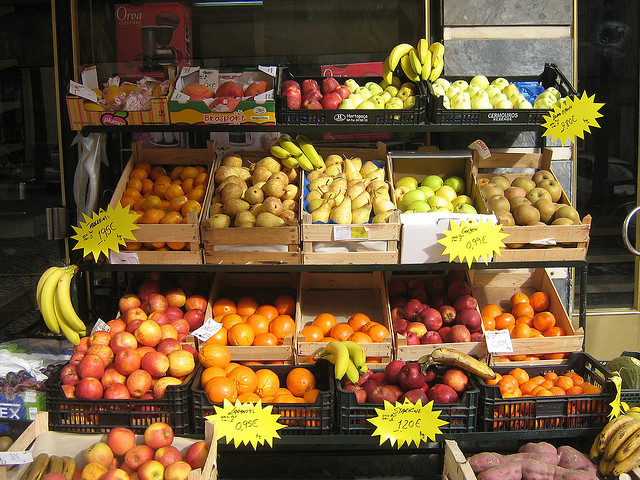Identify and read out the text in this image. Brosport 195C 9,99C 120E 0.95&#163; EX 